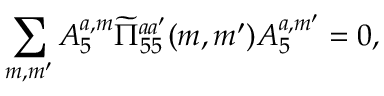Convert formula to latex. <formula><loc_0><loc_0><loc_500><loc_500>\sum _ { m , m ^ { \prime } } A _ { 5 } ^ { a , m } \widetilde { \Pi } _ { 5 5 } ^ { a a ^ { \prime } } ( m , m ^ { \prime } ) A _ { 5 } ^ { a , m ^ { \prime } } = 0 ,</formula> 